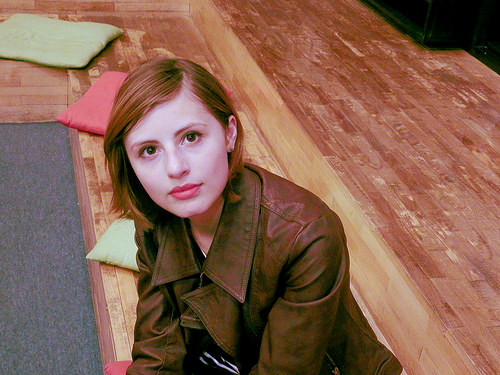<image>
Is there a pillow on the woman? No. The pillow is not positioned on the woman. They may be near each other, but the pillow is not supported by or resting on top of the woman. 